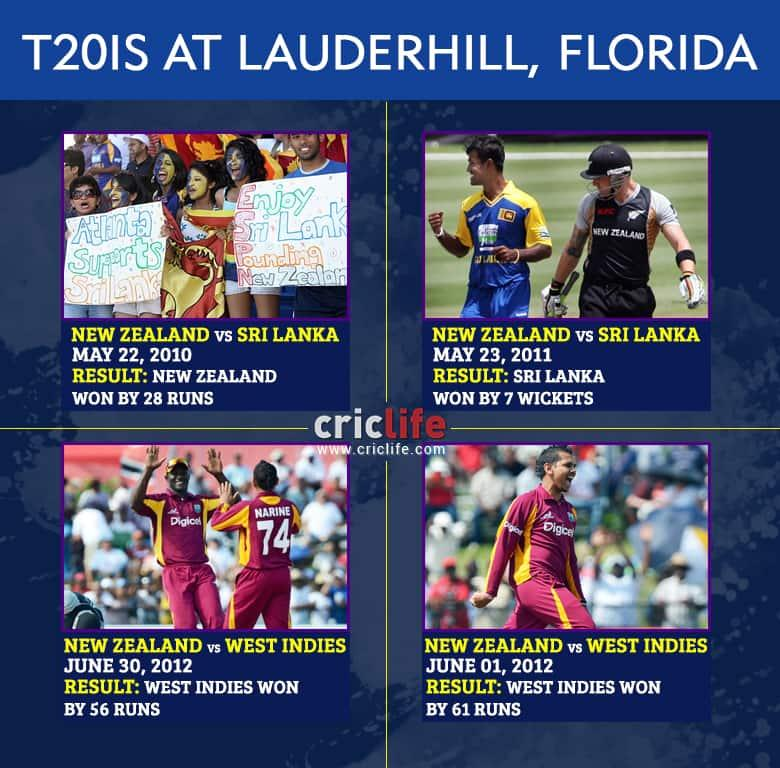List a handful of essential elements in this visual. New Zealand has won 1 game. The West Indies have won a total of two games. 